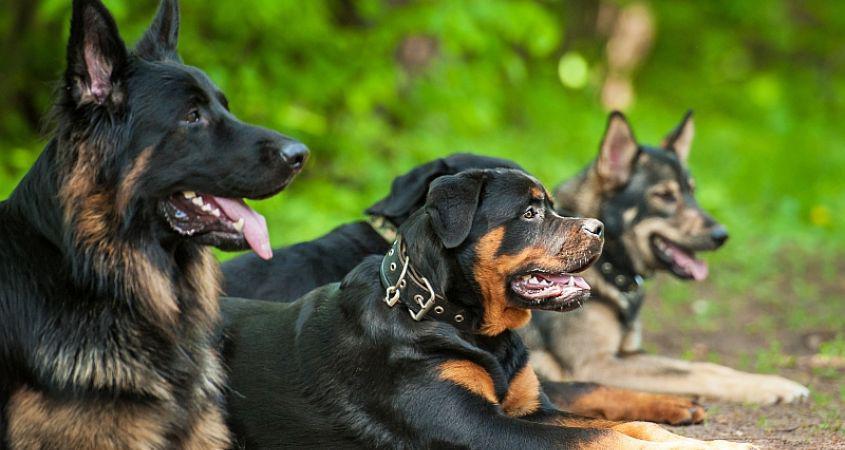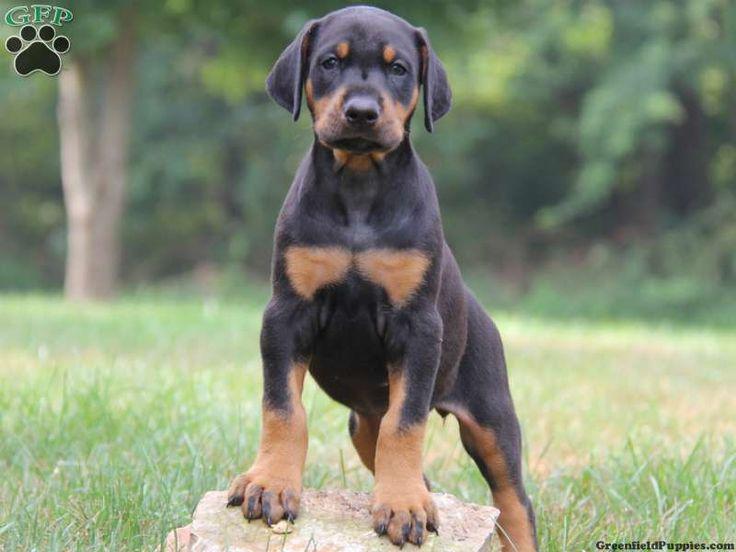The first image is the image on the left, the second image is the image on the right. Evaluate the accuracy of this statement regarding the images: "One picture has only three dogs posing together.". Is it true? Answer yes or no. No. The first image is the image on the left, the second image is the image on the right. Given the left and right images, does the statement "There are exactly five dogs in total." hold true? Answer yes or no. Yes. 